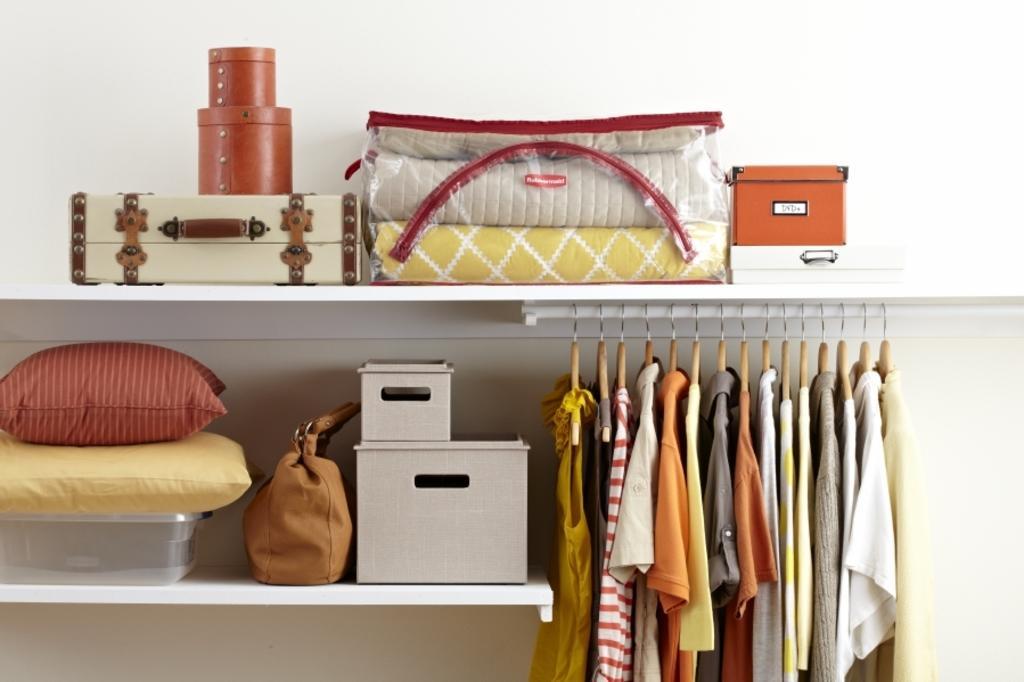In one or two sentences, can you explain what this image depicts? In this image i can see there is a shelf in which on the top of the shelf we can find few boxes and few blankets in a bag. On the second shelf there are few cushions, a bag and a few boxes. And on the right side of the image we can see few clothes are hanging in the shelf 